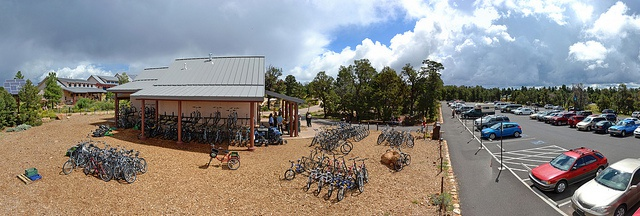Describe the objects in this image and their specific colors. I can see bicycle in gray, black, and maroon tones, car in gray, white, black, and darkgray tones, car in gray, black, maroon, and lightpink tones, car in gray, navy, black, and blue tones, and bicycle in gray, black, and tan tones in this image. 